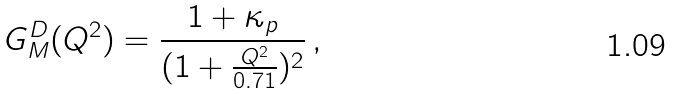Convert formula to latex. <formula><loc_0><loc_0><loc_500><loc_500>G _ { M } ^ { D } ( Q ^ { 2 } ) = \frac { 1 + \kappa _ { p } } { ( 1 + \frac { Q ^ { 2 } } { 0 . 7 1 } ) ^ { 2 } } \, ,</formula> 